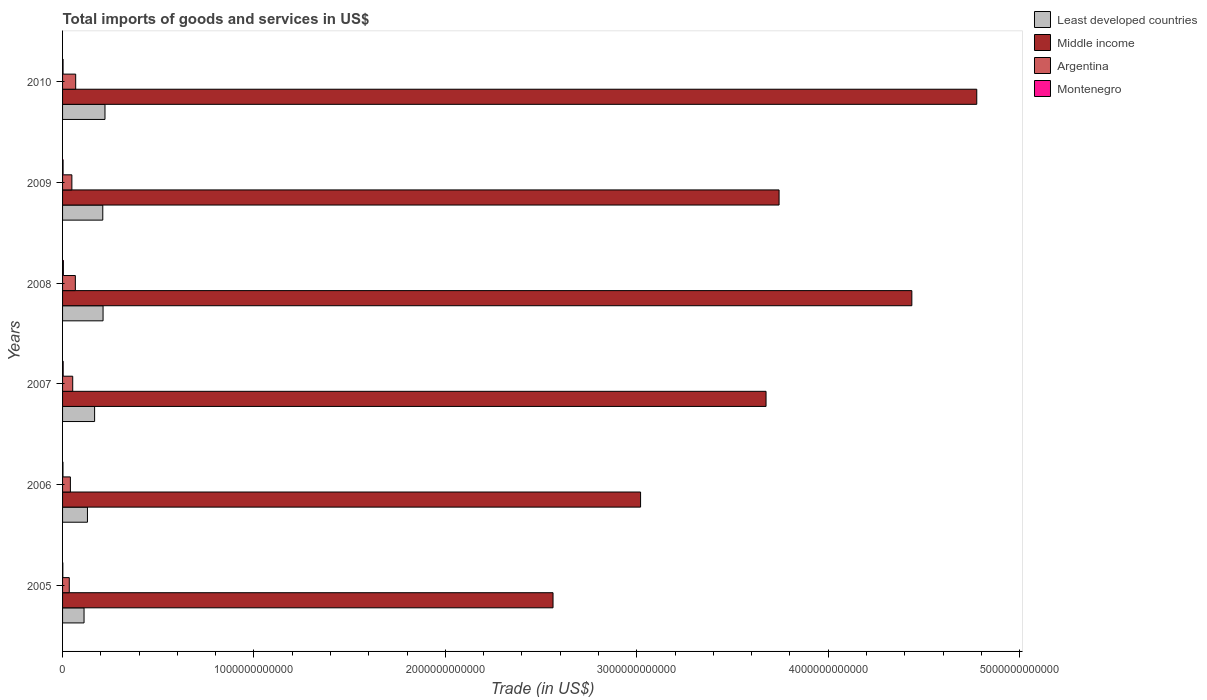How many bars are there on the 5th tick from the bottom?
Make the answer very short. 4. In how many cases, is the number of bars for a given year not equal to the number of legend labels?
Your answer should be very brief. 0. What is the total imports of goods and services in Middle income in 2006?
Offer a terse response. 3.02e+12. Across all years, what is the maximum total imports of goods and services in Least developed countries?
Offer a very short reply. 2.22e+11. Across all years, what is the minimum total imports of goods and services in Argentina?
Make the answer very short. 3.51e+1. In which year was the total imports of goods and services in Middle income minimum?
Keep it short and to the point. 2005. What is the total total imports of goods and services in Montenegro in the graph?
Provide a short and direct response. 1.62e+1. What is the difference between the total imports of goods and services in Middle income in 2006 and that in 2009?
Make the answer very short. -7.24e+11. What is the difference between the total imports of goods and services in Least developed countries in 2010 and the total imports of goods and services in Middle income in 2009?
Provide a short and direct response. -3.52e+12. What is the average total imports of goods and services in Middle income per year?
Ensure brevity in your answer.  3.70e+12. In the year 2008, what is the difference between the total imports of goods and services in Montenegro and total imports of goods and services in Middle income?
Keep it short and to the point. -4.43e+12. What is the ratio of the total imports of goods and services in Least developed countries in 2008 to that in 2009?
Provide a succinct answer. 1.01. Is the total imports of goods and services in Middle income in 2006 less than that in 2008?
Ensure brevity in your answer.  Yes. What is the difference between the highest and the second highest total imports of goods and services in Argentina?
Make the answer very short. 1.74e+09. What is the difference between the highest and the lowest total imports of goods and services in Middle income?
Ensure brevity in your answer.  2.21e+12. In how many years, is the total imports of goods and services in Middle income greater than the average total imports of goods and services in Middle income taken over all years?
Offer a very short reply. 3. Is the sum of the total imports of goods and services in Least developed countries in 2006 and 2007 greater than the maximum total imports of goods and services in Middle income across all years?
Offer a very short reply. No. Is it the case that in every year, the sum of the total imports of goods and services in Least developed countries and total imports of goods and services in Montenegro is greater than the sum of total imports of goods and services in Middle income and total imports of goods and services in Argentina?
Make the answer very short. No. What does the 4th bar from the top in 2006 represents?
Your answer should be very brief. Least developed countries. Is it the case that in every year, the sum of the total imports of goods and services in Middle income and total imports of goods and services in Argentina is greater than the total imports of goods and services in Montenegro?
Offer a very short reply. Yes. How many bars are there?
Offer a terse response. 24. Are all the bars in the graph horizontal?
Keep it short and to the point. Yes. How many years are there in the graph?
Provide a succinct answer. 6. What is the difference between two consecutive major ticks on the X-axis?
Provide a short and direct response. 1.00e+12. Does the graph contain grids?
Your answer should be compact. No. How are the legend labels stacked?
Ensure brevity in your answer.  Vertical. What is the title of the graph?
Your answer should be very brief. Total imports of goods and services in US$. Does "Turkey" appear as one of the legend labels in the graph?
Make the answer very short. No. What is the label or title of the X-axis?
Make the answer very short. Trade (in US$). What is the label or title of the Y-axis?
Offer a terse response. Years. What is the Trade (in US$) in Least developed countries in 2005?
Make the answer very short. 1.12e+11. What is the Trade (in US$) in Middle income in 2005?
Offer a terse response. 2.56e+12. What is the Trade (in US$) in Argentina in 2005?
Make the answer very short. 3.51e+1. What is the Trade (in US$) in Montenegro in 2005?
Your response must be concise. 1.38e+09. What is the Trade (in US$) in Least developed countries in 2006?
Your response must be concise. 1.30e+11. What is the Trade (in US$) in Middle income in 2006?
Give a very brief answer. 3.02e+12. What is the Trade (in US$) in Argentina in 2006?
Provide a succinct answer. 4.09e+1. What is the Trade (in US$) in Montenegro in 2006?
Your response must be concise. 2.13e+09. What is the Trade (in US$) in Least developed countries in 2007?
Give a very brief answer. 1.67e+11. What is the Trade (in US$) in Middle income in 2007?
Give a very brief answer. 3.68e+12. What is the Trade (in US$) of Argentina in 2007?
Keep it short and to the point. 5.30e+1. What is the Trade (in US$) of Montenegro in 2007?
Your answer should be compact. 3.18e+09. What is the Trade (in US$) in Least developed countries in 2008?
Provide a succinct answer. 2.12e+11. What is the Trade (in US$) of Middle income in 2008?
Give a very brief answer. 4.44e+12. What is the Trade (in US$) of Argentina in 2008?
Your answer should be very brief. 6.68e+1. What is the Trade (in US$) in Montenegro in 2008?
Offer a terse response. 4.25e+09. What is the Trade (in US$) in Least developed countries in 2009?
Keep it short and to the point. 2.10e+11. What is the Trade (in US$) of Middle income in 2009?
Keep it short and to the point. 3.74e+12. What is the Trade (in US$) of Argentina in 2009?
Offer a terse response. 4.87e+1. What is the Trade (in US$) of Montenegro in 2009?
Your answer should be very brief. 2.71e+09. What is the Trade (in US$) of Least developed countries in 2010?
Give a very brief answer. 2.22e+11. What is the Trade (in US$) in Middle income in 2010?
Ensure brevity in your answer.  4.78e+12. What is the Trade (in US$) of Argentina in 2010?
Provide a succinct answer. 6.85e+1. What is the Trade (in US$) in Montenegro in 2010?
Your response must be concise. 2.60e+09. Across all years, what is the maximum Trade (in US$) in Least developed countries?
Make the answer very short. 2.22e+11. Across all years, what is the maximum Trade (in US$) in Middle income?
Your response must be concise. 4.78e+12. Across all years, what is the maximum Trade (in US$) in Argentina?
Your answer should be compact. 6.85e+1. Across all years, what is the maximum Trade (in US$) of Montenegro?
Ensure brevity in your answer.  4.25e+09. Across all years, what is the minimum Trade (in US$) in Least developed countries?
Keep it short and to the point. 1.12e+11. Across all years, what is the minimum Trade (in US$) of Middle income?
Your answer should be very brief. 2.56e+12. Across all years, what is the minimum Trade (in US$) in Argentina?
Your response must be concise. 3.51e+1. Across all years, what is the minimum Trade (in US$) of Montenegro?
Offer a terse response. 1.38e+09. What is the total Trade (in US$) of Least developed countries in the graph?
Make the answer very short. 1.05e+12. What is the total Trade (in US$) in Middle income in the graph?
Offer a very short reply. 2.22e+13. What is the total Trade (in US$) in Argentina in the graph?
Offer a terse response. 3.13e+11. What is the total Trade (in US$) in Montenegro in the graph?
Offer a terse response. 1.62e+1. What is the difference between the Trade (in US$) of Least developed countries in 2005 and that in 2006?
Keep it short and to the point. -1.78e+1. What is the difference between the Trade (in US$) in Middle income in 2005 and that in 2006?
Make the answer very short. -4.57e+11. What is the difference between the Trade (in US$) of Argentina in 2005 and that in 2006?
Offer a terse response. -5.76e+09. What is the difference between the Trade (in US$) of Montenegro in 2005 and that in 2006?
Provide a short and direct response. -7.54e+08. What is the difference between the Trade (in US$) in Least developed countries in 2005 and that in 2007?
Provide a succinct answer. -5.52e+1. What is the difference between the Trade (in US$) of Middle income in 2005 and that in 2007?
Keep it short and to the point. -1.11e+12. What is the difference between the Trade (in US$) of Argentina in 2005 and that in 2007?
Give a very brief answer. -1.80e+1. What is the difference between the Trade (in US$) of Montenegro in 2005 and that in 2007?
Provide a short and direct response. -1.80e+09. What is the difference between the Trade (in US$) in Least developed countries in 2005 and that in 2008?
Offer a terse response. -9.94e+1. What is the difference between the Trade (in US$) of Middle income in 2005 and that in 2008?
Make the answer very short. -1.87e+12. What is the difference between the Trade (in US$) in Argentina in 2005 and that in 2008?
Offer a terse response. -3.17e+1. What is the difference between the Trade (in US$) in Montenegro in 2005 and that in 2008?
Offer a terse response. -2.87e+09. What is the difference between the Trade (in US$) in Least developed countries in 2005 and that in 2009?
Make the answer very short. -9.79e+1. What is the difference between the Trade (in US$) of Middle income in 2005 and that in 2009?
Keep it short and to the point. -1.18e+12. What is the difference between the Trade (in US$) of Argentina in 2005 and that in 2009?
Offer a terse response. -1.36e+1. What is the difference between the Trade (in US$) in Montenegro in 2005 and that in 2009?
Keep it short and to the point. -1.33e+09. What is the difference between the Trade (in US$) of Least developed countries in 2005 and that in 2010?
Ensure brevity in your answer.  -1.09e+11. What is the difference between the Trade (in US$) of Middle income in 2005 and that in 2010?
Your answer should be very brief. -2.21e+12. What is the difference between the Trade (in US$) of Argentina in 2005 and that in 2010?
Give a very brief answer. -3.34e+1. What is the difference between the Trade (in US$) of Montenegro in 2005 and that in 2010?
Your answer should be very brief. -1.22e+09. What is the difference between the Trade (in US$) in Least developed countries in 2006 and that in 2007?
Your response must be concise. -3.74e+1. What is the difference between the Trade (in US$) of Middle income in 2006 and that in 2007?
Your answer should be very brief. -6.56e+11. What is the difference between the Trade (in US$) in Argentina in 2006 and that in 2007?
Your response must be concise. -1.22e+1. What is the difference between the Trade (in US$) in Montenegro in 2006 and that in 2007?
Your response must be concise. -1.05e+09. What is the difference between the Trade (in US$) in Least developed countries in 2006 and that in 2008?
Make the answer very short. -8.16e+1. What is the difference between the Trade (in US$) of Middle income in 2006 and that in 2008?
Provide a short and direct response. -1.42e+12. What is the difference between the Trade (in US$) of Argentina in 2006 and that in 2008?
Keep it short and to the point. -2.59e+1. What is the difference between the Trade (in US$) of Montenegro in 2006 and that in 2008?
Offer a very short reply. -2.12e+09. What is the difference between the Trade (in US$) in Least developed countries in 2006 and that in 2009?
Make the answer very short. -8.01e+1. What is the difference between the Trade (in US$) in Middle income in 2006 and that in 2009?
Keep it short and to the point. -7.24e+11. What is the difference between the Trade (in US$) in Argentina in 2006 and that in 2009?
Your answer should be very brief. -7.80e+09. What is the difference between the Trade (in US$) in Montenegro in 2006 and that in 2009?
Provide a succinct answer. -5.77e+08. What is the difference between the Trade (in US$) in Least developed countries in 2006 and that in 2010?
Keep it short and to the point. -9.16e+1. What is the difference between the Trade (in US$) of Middle income in 2006 and that in 2010?
Provide a succinct answer. -1.76e+12. What is the difference between the Trade (in US$) of Argentina in 2006 and that in 2010?
Provide a succinct answer. -2.77e+1. What is the difference between the Trade (in US$) of Montenegro in 2006 and that in 2010?
Give a very brief answer. -4.64e+08. What is the difference between the Trade (in US$) in Least developed countries in 2007 and that in 2008?
Your response must be concise. -4.42e+1. What is the difference between the Trade (in US$) in Middle income in 2007 and that in 2008?
Your answer should be very brief. -7.62e+11. What is the difference between the Trade (in US$) of Argentina in 2007 and that in 2008?
Give a very brief answer. -1.37e+1. What is the difference between the Trade (in US$) of Montenegro in 2007 and that in 2008?
Offer a terse response. -1.07e+09. What is the difference between the Trade (in US$) of Least developed countries in 2007 and that in 2009?
Provide a short and direct response. -4.27e+1. What is the difference between the Trade (in US$) in Middle income in 2007 and that in 2009?
Give a very brief answer. -6.81e+1. What is the difference between the Trade (in US$) of Argentina in 2007 and that in 2009?
Offer a very short reply. 4.40e+09. What is the difference between the Trade (in US$) in Montenegro in 2007 and that in 2009?
Your answer should be very brief. 4.72e+08. What is the difference between the Trade (in US$) of Least developed countries in 2007 and that in 2010?
Your response must be concise. -5.42e+1. What is the difference between the Trade (in US$) of Middle income in 2007 and that in 2010?
Your response must be concise. -1.10e+12. What is the difference between the Trade (in US$) in Argentina in 2007 and that in 2010?
Ensure brevity in your answer.  -1.55e+1. What is the difference between the Trade (in US$) in Montenegro in 2007 and that in 2010?
Keep it short and to the point. 5.84e+08. What is the difference between the Trade (in US$) in Least developed countries in 2008 and that in 2009?
Provide a short and direct response. 1.49e+09. What is the difference between the Trade (in US$) in Middle income in 2008 and that in 2009?
Keep it short and to the point. 6.94e+11. What is the difference between the Trade (in US$) of Argentina in 2008 and that in 2009?
Keep it short and to the point. 1.81e+1. What is the difference between the Trade (in US$) in Montenegro in 2008 and that in 2009?
Give a very brief answer. 1.54e+09. What is the difference between the Trade (in US$) in Least developed countries in 2008 and that in 2010?
Keep it short and to the point. -1.00e+1. What is the difference between the Trade (in US$) of Middle income in 2008 and that in 2010?
Offer a terse response. -3.39e+11. What is the difference between the Trade (in US$) of Argentina in 2008 and that in 2010?
Provide a short and direct response. -1.74e+09. What is the difference between the Trade (in US$) in Montenegro in 2008 and that in 2010?
Ensure brevity in your answer.  1.65e+09. What is the difference between the Trade (in US$) in Least developed countries in 2009 and that in 2010?
Keep it short and to the point. -1.15e+1. What is the difference between the Trade (in US$) in Middle income in 2009 and that in 2010?
Your answer should be very brief. -1.03e+12. What is the difference between the Trade (in US$) of Argentina in 2009 and that in 2010?
Your answer should be compact. -1.99e+1. What is the difference between the Trade (in US$) of Montenegro in 2009 and that in 2010?
Offer a very short reply. 1.13e+08. What is the difference between the Trade (in US$) of Least developed countries in 2005 and the Trade (in US$) of Middle income in 2006?
Make the answer very short. -2.91e+12. What is the difference between the Trade (in US$) of Least developed countries in 2005 and the Trade (in US$) of Argentina in 2006?
Provide a short and direct response. 7.14e+1. What is the difference between the Trade (in US$) of Least developed countries in 2005 and the Trade (in US$) of Montenegro in 2006?
Provide a succinct answer. 1.10e+11. What is the difference between the Trade (in US$) of Middle income in 2005 and the Trade (in US$) of Argentina in 2006?
Ensure brevity in your answer.  2.52e+12. What is the difference between the Trade (in US$) in Middle income in 2005 and the Trade (in US$) in Montenegro in 2006?
Your answer should be compact. 2.56e+12. What is the difference between the Trade (in US$) in Argentina in 2005 and the Trade (in US$) in Montenegro in 2006?
Make the answer very short. 3.30e+1. What is the difference between the Trade (in US$) of Least developed countries in 2005 and the Trade (in US$) of Middle income in 2007?
Provide a short and direct response. -3.56e+12. What is the difference between the Trade (in US$) of Least developed countries in 2005 and the Trade (in US$) of Argentina in 2007?
Offer a terse response. 5.92e+1. What is the difference between the Trade (in US$) of Least developed countries in 2005 and the Trade (in US$) of Montenegro in 2007?
Ensure brevity in your answer.  1.09e+11. What is the difference between the Trade (in US$) in Middle income in 2005 and the Trade (in US$) in Argentina in 2007?
Ensure brevity in your answer.  2.51e+12. What is the difference between the Trade (in US$) of Middle income in 2005 and the Trade (in US$) of Montenegro in 2007?
Give a very brief answer. 2.56e+12. What is the difference between the Trade (in US$) in Argentina in 2005 and the Trade (in US$) in Montenegro in 2007?
Your answer should be compact. 3.19e+1. What is the difference between the Trade (in US$) of Least developed countries in 2005 and the Trade (in US$) of Middle income in 2008?
Your answer should be very brief. -4.32e+12. What is the difference between the Trade (in US$) of Least developed countries in 2005 and the Trade (in US$) of Argentina in 2008?
Your answer should be compact. 4.54e+1. What is the difference between the Trade (in US$) of Least developed countries in 2005 and the Trade (in US$) of Montenegro in 2008?
Offer a very short reply. 1.08e+11. What is the difference between the Trade (in US$) of Middle income in 2005 and the Trade (in US$) of Argentina in 2008?
Offer a very short reply. 2.50e+12. What is the difference between the Trade (in US$) in Middle income in 2005 and the Trade (in US$) in Montenegro in 2008?
Your response must be concise. 2.56e+12. What is the difference between the Trade (in US$) in Argentina in 2005 and the Trade (in US$) in Montenegro in 2008?
Your answer should be very brief. 3.08e+1. What is the difference between the Trade (in US$) in Least developed countries in 2005 and the Trade (in US$) in Middle income in 2009?
Your response must be concise. -3.63e+12. What is the difference between the Trade (in US$) of Least developed countries in 2005 and the Trade (in US$) of Argentina in 2009?
Offer a terse response. 6.36e+1. What is the difference between the Trade (in US$) of Least developed countries in 2005 and the Trade (in US$) of Montenegro in 2009?
Provide a short and direct response. 1.09e+11. What is the difference between the Trade (in US$) in Middle income in 2005 and the Trade (in US$) in Argentina in 2009?
Your answer should be very brief. 2.51e+12. What is the difference between the Trade (in US$) of Middle income in 2005 and the Trade (in US$) of Montenegro in 2009?
Offer a very short reply. 2.56e+12. What is the difference between the Trade (in US$) of Argentina in 2005 and the Trade (in US$) of Montenegro in 2009?
Make the answer very short. 3.24e+1. What is the difference between the Trade (in US$) of Least developed countries in 2005 and the Trade (in US$) of Middle income in 2010?
Your response must be concise. -4.66e+12. What is the difference between the Trade (in US$) in Least developed countries in 2005 and the Trade (in US$) in Argentina in 2010?
Provide a short and direct response. 4.37e+1. What is the difference between the Trade (in US$) in Least developed countries in 2005 and the Trade (in US$) in Montenegro in 2010?
Provide a short and direct response. 1.10e+11. What is the difference between the Trade (in US$) in Middle income in 2005 and the Trade (in US$) in Argentina in 2010?
Keep it short and to the point. 2.49e+12. What is the difference between the Trade (in US$) in Middle income in 2005 and the Trade (in US$) in Montenegro in 2010?
Give a very brief answer. 2.56e+12. What is the difference between the Trade (in US$) in Argentina in 2005 and the Trade (in US$) in Montenegro in 2010?
Give a very brief answer. 3.25e+1. What is the difference between the Trade (in US$) in Least developed countries in 2006 and the Trade (in US$) in Middle income in 2007?
Your answer should be very brief. -3.55e+12. What is the difference between the Trade (in US$) in Least developed countries in 2006 and the Trade (in US$) in Argentina in 2007?
Keep it short and to the point. 7.70e+1. What is the difference between the Trade (in US$) of Least developed countries in 2006 and the Trade (in US$) of Montenegro in 2007?
Your answer should be compact. 1.27e+11. What is the difference between the Trade (in US$) of Middle income in 2006 and the Trade (in US$) of Argentina in 2007?
Make the answer very short. 2.97e+12. What is the difference between the Trade (in US$) of Middle income in 2006 and the Trade (in US$) of Montenegro in 2007?
Provide a succinct answer. 3.02e+12. What is the difference between the Trade (in US$) in Argentina in 2006 and the Trade (in US$) in Montenegro in 2007?
Offer a terse response. 3.77e+1. What is the difference between the Trade (in US$) in Least developed countries in 2006 and the Trade (in US$) in Middle income in 2008?
Give a very brief answer. -4.31e+12. What is the difference between the Trade (in US$) in Least developed countries in 2006 and the Trade (in US$) in Argentina in 2008?
Ensure brevity in your answer.  6.32e+1. What is the difference between the Trade (in US$) of Least developed countries in 2006 and the Trade (in US$) of Montenegro in 2008?
Offer a terse response. 1.26e+11. What is the difference between the Trade (in US$) in Middle income in 2006 and the Trade (in US$) in Argentina in 2008?
Your answer should be compact. 2.95e+12. What is the difference between the Trade (in US$) of Middle income in 2006 and the Trade (in US$) of Montenegro in 2008?
Provide a short and direct response. 3.02e+12. What is the difference between the Trade (in US$) in Argentina in 2006 and the Trade (in US$) in Montenegro in 2008?
Provide a succinct answer. 3.66e+1. What is the difference between the Trade (in US$) in Least developed countries in 2006 and the Trade (in US$) in Middle income in 2009?
Give a very brief answer. -3.61e+12. What is the difference between the Trade (in US$) of Least developed countries in 2006 and the Trade (in US$) of Argentina in 2009?
Provide a short and direct response. 8.14e+1. What is the difference between the Trade (in US$) of Least developed countries in 2006 and the Trade (in US$) of Montenegro in 2009?
Provide a succinct answer. 1.27e+11. What is the difference between the Trade (in US$) of Middle income in 2006 and the Trade (in US$) of Argentina in 2009?
Give a very brief answer. 2.97e+12. What is the difference between the Trade (in US$) of Middle income in 2006 and the Trade (in US$) of Montenegro in 2009?
Give a very brief answer. 3.02e+12. What is the difference between the Trade (in US$) in Argentina in 2006 and the Trade (in US$) in Montenegro in 2009?
Provide a succinct answer. 3.81e+1. What is the difference between the Trade (in US$) of Least developed countries in 2006 and the Trade (in US$) of Middle income in 2010?
Your response must be concise. -4.65e+12. What is the difference between the Trade (in US$) of Least developed countries in 2006 and the Trade (in US$) of Argentina in 2010?
Provide a succinct answer. 6.15e+1. What is the difference between the Trade (in US$) of Least developed countries in 2006 and the Trade (in US$) of Montenegro in 2010?
Your response must be concise. 1.27e+11. What is the difference between the Trade (in US$) in Middle income in 2006 and the Trade (in US$) in Argentina in 2010?
Provide a succinct answer. 2.95e+12. What is the difference between the Trade (in US$) of Middle income in 2006 and the Trade (in US$) of Montenegro in 2010?
Your answer should be compact. 3.02e+12. What is the difference between the Trade (in US$) of Argentina in 2006 and the Trade (in US$) of Montenegro in 2010?
Make the answer very short. 3.83e+1. What is the difference between the Trade (in US$) in Least developed countries in 2007 and the Trade (in US$) in Middle income in 2008?
Offer a very short reply. -4.27e+12. What is the difference between the Trade (in US$) of Least developed countries in 2007 and the Trade (in US$) of Argentina in 2008?
Your answer should be compact. 1.01e+11. What is the difference between the Trade (in US$) of Least developed countries in 2007 and the Trade (in US$) of Montenegro in 2008?
Give a very brief answer. 1.63e+11. What is the difference between the Trade (in US$) in Middle income in 2007 and the Trade (in US$) in Argentina in 2008?
Give a very brief answer. 3.61e+12. What is the difference between the Trade (in US$) in Middle income in 2007 and the Trade (in US$) in Montenegro in 2008?
Offer a very short reply. 3.67e+12. What is the difference between the Trade (in US$) in Argentina in 2007 and the Trade (in US$) in Montenegro in 2008?
Your answer should be compact. 4.88e+1. What is the difference between the Trade (in US$) in Least developed countries in 2007 and the Trade (in US$) in Middle income in 2009?
Make the answer very short. -3.58e+12. What is the difference between the Trade (in US$) of Least developed countries in 2007 and the Trade (in US$) of Argentina in 2009?
Provide a succinct answer. 1.19e+11. What is the difference between the Trade (in US$) in Least developed countries in 2007 and the Trade (in US$) in Montenegro in 2009?
Provide a succinct answer. 1.65e+11. What is the difference between the Trade (in US$) of Middle income in 2007 and the Trade (in US$) of Argentina in 2009?
Offer a terse response. 3.63e+12. What is the difference between the Trade (in US$) in Middle income in 2007 and the Trade (in US$) in Montenegro in 2009?
Provide a short and direct response. 3.67e+12. What is the difference between the Trade (in US$) of Argentina in 2007 and the Trade (in US$) of Montenegro in 2009?
Your answer should be very brief. 5.03e+1. What is the difference between the Trade (in US$) in Least developed countries in 2007 and the Trade (in US$) in Middle income in 2010?
Give a very brief answer. -4.61e+12. What is the difference between the Trade (in US$) of Least developed countries in 2007 and the Trade (in US$) of Argentina in 2010?
Offer a terse response. 9.89e+1. What is the difference between the Trade (in US$) in Least developed countries in 2007 and the Trade (in US$) in Montenegro in 2010?
Your answer should be compact. 1.65e+11. What is the difference between the Trade (in US$) of Middle income in 2007 and the Trade (in US$) of Argentina in 2010?
Offer a terse response. 3.61e+12. What is the difference between the Trade (in US$) of Middle income in 2007 and the Trade (in US$) of Montenegro in 2010?
Offer a very short reply. 3.67e+12. What is the difference between the Trade (in US$) in Argentina in 2007 and the Trade (in US$) in Montenegro in 2010?
Give a very brief answer. 5.05e+1. What is the difference between the Trade (in US$) of Least developed countries in 2008 and the Trade (in US$) of Middle income in 2009?
Provide a succinct answer. -3.53e+12. What is the difference between the Trade (in US$) of Least developed countries in 2008 and the Trade (in US$) of Argentina in 2009?
Your answer should be compact. 1.63e+11. What is the difference between the Trade (in US$) of Least developed countries in 2008 and the Trade (in US$) of Montenegro in 2009?
Ensure brevity in your answer.  2.09e+11. What is the difference between the Trade (in US$) of Middle income in 2008 and the Trade (in US$) of Argentina in 2009?
Offer a very short reply. 4.39e+12. What is the difference between the Trade (in US$) of Middle income in 2008 and the Trade (in US$) of Montenegro in 2009?
Keep it short and to the point. 4.43e+12. What is the difference between the Trade (in US$) of Argentina in 2008 and the Trade (in US$) of Montenegro in 2009?
Your response must be concise. 6.41e+1. What is the difference between the Trade (in US$) in Least developed countries in 2008 and the Trade (in US$) in Middle income in 2010?
Your answer should be compact. -4.56e+12. What is the difference between the Trade (in US$) of Least developed countries in 2008 and the Trade (in US$) of Argentina in 2010?
Provide a succinct answer. 1.43e+11. What is the difference between the Trade (in US$) in Least developed countries in 2008 and the Trade (in US$) in Montenegro in 2010?
Keep it short and to the point. 2.09e+11. What is the difference between the Trade (in US$) in Middle income in 2008 and the Trade (in US$) in Argentina in 2010?
Give a very brief answer. 4.37e+12. What is the difference between the Trade (in US$) of Middle income in 2008 and the Trade (in US$) of Montenegro in 2010?
Ensure brevity in your answer.  4.43e+12. What is the difference between the Trade (in US$) in Argentina in 2008 and the Trade (in US$) in Montenegro in 2010?
Provide a short and direct response. 6.42e+1. What is the difference between the Trade (in US$) in Least developed countries in 2009 and the Trade (in US$) in Middle income in 2010?
Ensure brevity in your answer.  -4.57e+12. What is the difference between the Trade (in US$) in Least developed countries in 2009 and the Trade (in US$) in Argentina in 2010?
Ensure brevity in your answer.  1.42e+11. What is the difference between the Trade (in US$) of Least developed countries in 2009 and the Trade (in US$) of Montenegro in 2010?
Your answer should be very brief. 2.07e+11. What is the difference between the Trade (in US$) of Middle income in 2009 and the Trade (in US$) of Argentina in 2010?
Give a very brief answer. 3.67e+12. What is the difference between the Trade (in US$) in Middle income in 2009 and the Trade (in US$) in Montenegro in 2010?
Keep it short and to the point. 3.74e+12. What is the difference between the Trade (in US$) of Argentina in 2009 and the Trade (in US$) of Montenegro in 2010?
Your answer should be very brief. 4.61e+1. What is the average Trade (in US$) of Least developed countries per year?
Make the answer very short. 1.75e+11. What is the average Trade (in US$) of Middle income per year?
Ensure brevity in your answer.  3.70e+12. What is the average Trade (in US$) in Argentina per year?
Make the answer very short. 5.22e+1. What is the average Trade (in US$) of Montenegro per year?
Keep it short and to the point. 2.71e+09. In the year 2005, what is the difference between the Trade (in US$) of Least developed countries and Trade (in US$) of Middle income?
Offer a terse response. -2.45e+12. In the year 2005, what is the difference between the Trade (in US$) of Least developed countries and Trade (in US$) of Argentina?
Give a very brief answer. 7.71e+1. In the year 2005, what is the difference between the Trade (in US$) of Least developed countries and Trade (in US$) of Montenegro?
Your response must be concise. 1.11e+11. In the year 2005, what is the difference between the Trade (in US$) of Middle income and Trade (in US$) of Argentina?
Provide a succinct answer. 2.53e+12. In the year 2005, what is the difference between the Trade (in US$) in Middle income and Trade (in US$) in Montenegro?
Offer a terse response. 2.56e+12. In the year 2005, what is the difference between the Trade (in US$) in Argentina and Trade (in US$) in Montenegro?
Your answer should be compact. 3.37e+1. In the year 2006, what is the difference between the Trade (in US$) of Least developed countries and Trade (in US$) of Middle income?
Your response must be concise. -2.89e+12. In the year 2006, what is the difference between the Trade (in US$) in Least developed countries and Trade (in US$) in Argentina?
Your answer should be compact. 8.92e+1. In the year 2006, what is the difference between the Trade (in US$) in Least developed countries and Trade (in US$) in Montenegro?
Your response must be concise. 1.28e+11. In the year 2006, what is the difference between the Trade (in US$) in Middle income and Trade (in US$) in Argentina?
Your answer should be very brief. 2.98e+12. In the year 2006, what is the difference between the Trade (in US$) in Middle income and Trade (in US$) in Montenegro?
Keep it short and to the point. 3.02e+12. In the year 2006, what is the difference between the Trade (in US$) of Argentina and Trade (in US$) of Montenegro?
Keep it short and to the point. 3.87e+1. In the year 2007, what is the difference between the Trade (in US$) of Least developed countries and Trade (in US$) of Middle income?
Your response must be concise. -3.51e+12. In the year 2007, what is the difference between the Trade (in US$) of Least developed countries and Trade (in US$) of Argentina?
Your response must be concise. 1.14e+11. In the year 2007, what is the difference between the Trade (in US$) in Least developed countries and Trade (in US$) in Montenegro?
Your response must be concise. 1.64e+11. In the year 2007, what is the difference between the Trade (in US$) of Middle income and Trade (in US$) of Argentina?
Keep it short and to the point. 3.62e+12. In the year 2007, what is the difference between the Trade (in US$) of Middle income and Trade (in US$) of Montenegro?
Provide a succinct answer. 3.67e+12. In the year 2007, what is the difference between the Trade (in US$) in Argentina and Trade (in US$) in Montenegro?
Your response must be concise. 4.99e+1. In the year 2008, what is the difference between the Trade (in US$) in Least developed countries and Trade (in US$) in Middle income?
Offer a terse response. -4.23e+12. In the year 2008, what is the difference between the Trade (in US$) of Least developed countries and Trade (in US$) of Argentina?
Provide a succinct answer. 1.45e+11. In the year 2008, what is the difference between the Trade (in US$) of Least developed countries and Trade (in US$) of Montenegro?
Your answer should be very brief. 2.07e+11. In the year 2008, what is the difference between the Trade (in US$) of Middle income and Trade (in US$) of Argentina?
Provide a succinct answer. 4.37e+12. In the year 2008, what is the difference between the Trade (in US$) of Middle income and Trade (in US$) of Montenegro?
Give a very brief answer. 4.43e+12. In the year 2008, what is the difference between the Trade (in US$) of Argentina and Trade (in US$) of Montenegro?
Provide a short and direct response. 6.25e+1. In the year 2009, what is the difference between the Trade (in US$) of Least developed countries and Trade (in US$) of Middle income?
Offer a terse response. -3.53e+12. In the year 2009, what is the difference between the Trade (in US$) in Least developed countries and Trade (in US$) in Argentina?
Offer a terse response. 1.61e+11. In the year 2009, what is the difference between the Trade (in US$) of Least developed countries and Trade (in US$) of Montenegro?
Provide a succinct answer. 2.07e+11. In the year 2009, what is the difference between the Trade (in US$) in Middle income and Trade (in US$) in Argentina?
Offer a very short reply. 3.69e+12. In the year 2009, what is the difference between the Trade (in US$) in Middle income and Trade (in US$) in Montenegro?
Provide a short and direct response. 3.74e+12. In the year 2009, what is the difference between the Trade (in US$) in Argentina and Trade (in US$) in Montenegro?
Provide a succinct answer. 4.59e+1. In the year 2010, what is the difference between the Trade (in US$) of Least developed countries and Trade (in US$) of Middle income?
Offer a very short reply. -4.55e+12. In the year 2010, what is the difference between the Trade (in US$) in Least developed countries and Trade (in US$) in Argentina?
Your answer should be very brief. 1.53e+11. In the year 2010, what is the difference between the Trade (in US$) in Least developed countries and Trade (in US$) in Montenegro?
Offer a very short reply. 2.19e+11. In the year 2010, what is the difference between the Trade (in US$) of Middle income and Trade (in US$) of Argentina?
Provide a short and direct response. 4.71e+12. In the year 2010, what is the difference between the Trade (in US$) of Middle income and Trade (in US$) of Montenegro?
Offer a terse response. 4.77e+12. In the year 2010, what is the difference between the Trade (in US$) in Argentina and Trade (in US$) in Montenegro?
Ensure brevity in your answer.  6.59e+1. What is the ratio of the Trade (in US$) in Least developed countries in 2005 to that in 2006?
Keep it short and to the point. 0.86. What is the ratio of the Trade (in US$) of Middle income in 2005 to that in 2006?
Offer a very short reply. 0.85. What is the ratio of the Trade (in US$) in Argentina in 2005 to that in 2006?
Ensure brevity in your answer.  0.86. What is the ratio of the Trade (in US$) in Montenegro in 2005 to that in 2006?
Make the answer very short. 0.65. What is the ratio of the Trade (in US$) of Least developed countries in 2005 to that in 2007?
Offer a very short reply. 0.67. What is the ratio of the Trade (in US$) of Middle income in 2005 to that in 2007?
Give a very brief answer. 0.7. What is the ratio of the Trade (in US$) of Argentina in 2005 to that in 2007?
Give a very brief answer. 0.66. What is the ratio of the Trade (in US$) of Montenegro in 2005 to that in 2007?
Offer a terse response. 0.43. What is the ratio of the Trade (in US$) in Least developed countries in 2005 to that in 2008?
Offer a very short reply. 0.53. What is the ratio of the Trade (in US$) of Middle income in 2005 to that in 2008?
Make the answer very short. 0.58. What is the ratio of the Trade (in US$) of Argentina in 2005 to that in 2008?
Provide a short and direct response. 0.53. What is the ratio of the Trade (in US$) of Montenegro in 2005 to that in 2008?
Your answer should be compact. 0.32. What is the ratio of the Trade (in US$) in Least developed countries in 2005 to that in 2009?
Offer a very short reply. 0.53. What is the ratio of the Trade (in US$) in Middle income in 2005 to that in 2009?
Make the answer very short. 0.68. What is the ratio of the Trade (in US$) of Argentina in 2005 to that in 2009?
Your answer should be very brief. 0.72. What is the ratio of the Trade (in US$) in Montenegro in 2005 to that in 2009?
Your answer should be very brief. 0.51. What is the ratio of the Trade (in US$) in Least developed countries in 2005 to that in 2010?
Ensure brevity in your answer.  0.51. What is the ratio of the Trade (in US$) of Middle income in 2005 to that in 2010?
Provide a succinct answer. 0.54. What is the ratio of the Trade (in US$) of Argentina in 2005 to that in 2010?
Ensure brevity in your answer.  0.51. What is the ratio of the Trade (in US$) in Montenegro in 2005 to that in 2010?
Keep it short and to the point. 0.53. What is the ratio of the Trade (in US$) in Least developed countries in 2006 to that in 2007?
Make the answer very short. 0.78. What is the ratio of the Trade (in US$) in Middle income in 2006 to that in 2007?
Your answer should be compact. 0.82. What is the ratio of the Trade (in US$) in Argentina in 2006 to that in 2007?
Give a very brief answer. 0.77. What is the ratio of the Trade (in US$) in Montenegro in 2006 to that in 2007?
Your answer should be compact. 0.67. What is the ratio of the Trade (in US$) in Least developed countries in 2006 to that in 2008?
Your answer should be very brief. 0.61. What is the ratio of the Trade (in US$) in Middle income in 2006 to that in 2008?
Make the answer very short. 0.68. What is the ratio of the Trade (in US$) in Argentina in 2006 to that in 2008?
Provide a short and direct response. 0.61. What is the ratio of the Trade (in US$) of Montenegro in 2006 to that in 2008?
Your answer should be compact. 0.5. What is the ratio of the Trade (in US$) of Least developed countries in 2006 to that in 2009?
Offer a very short reply. 0.62. What is the ratio of the Trade (in US$) in Middle income in 2006 to that in 2009?
Your answer should be compact. 0.81. What is the ratio of the Trade (in US$) of Argentina in 2006 to that in 2009?
Make the answer very short. 0.84. What is the ratio of the Trade (in US$) of Montenegro in 2006 to that in 2009?
Offer a terse response. 0.79. What is the ratio of the Trade (in US$) of Least developed countries in 2006 to that in 2010?
Give a very brief answer. 0.59. What is the ratio of the Trade (in US$) in Middle income in 2006 to that in 2010?
Provide a short and direct response. 0.63. What is the ratio of the Trade (in US$) of Argentina in 2006 to that in 2010?
Provide a succinct answer. 0.6. What is the ratio of the Trade (in US$) in Montenegro in 2006 to that in 2010?
Your answer should be compact. 0.82. What is the ratio of the Trade (in US$) of Least developed countries in 2007 to that in 2008?
Offer a very short reply. 0.79. What is the ratio of the Trade (in US$) of Middle income in 2007 to that in 2008?
Offer a terse response. 0.83. What is the ratio of the Trade (in US$) of Argentina in 2007 to that in 2008?
Make the answer very short. 0.79. What is the ratio of the Trade (in US$) in Montenegro in 2007 to that in 2008?
Your answer should be compact. 0.75. What is the ratio of the Trade (in US$) in Least developed countries in 2007 to that in 2009?
Ensure brevity in your answer.  0.8. What is the ratio of the Trade (in US$) of Middle income in 2007 to that in 2009?
Keep it short and to the point. 0.98. What is the ratio of the Trade (in US$) of Argentina in 2007 to that in 2009?
Provide a succinct answer. 1.09. What is the ratio of the Trade (in US$) of Montenegro in 2007 to that in 2009?
Your answer should be compact. 1.17. What is the ratio of the Trade (in US$) of Least developed countries in 2007 to that in 2010?
Keep it short and to the point. 0.76. What is the ratio of the Trade (in US$) of Middle income in 2007 to that in 2010?
Your response must be concise. 0.77. What is the ratio of the Trade (in US$) of Argentina in 2007 to that in 2010?
Ensure brevity in your answer.  0.77. What is the ratio of the Trade (in US$) in Montenegro in 2007 to that in 2010?
Your answer should be compact. 1.22. What is the ratio of the Trade (in US$) of Least developed countries in 2008 to that in 2009?
Make the answer very short. 1.01. What is the ratio of the Trade (in US$) of Middle income in 2008 to that in 2009?
Your response must be concise. 1.19. What is the ratio of the Trade (in US$) of Argentina in 2008 to that in 2009?
Ensure brevity in your answer.  1.37. What is the ratio of the Trade (in US$) of Montenegro in 2008 to that in 2009?
Your answer should be very brief. 1.57. What is the ratio of the Trade (in US$) of Least developed countries in 2008 to that in 2010?
Keep it short and to the point. 0.95. What is the ratio of the Trade (in US$) of Middle income in 2008 to that in 2010?
Your answer should be very brief. 0.93. What is the ratio of the Trade (in US$) in Argentina in 2008 to that in 2010?
Give a very brief answer. 0.97. What is the ratio of the Trade (in US$) of Montenegro in 2008 to that in 2010?
Make the answer very short. 1.64. What is the ratio of the Trade (in US$) in Least developed countries in 2009 to that in 2010?
Offer a very short reply. 0.95. What is the ratio of the Trade (in US$) in Middle income in 2009 to that in 2010?
Your answer should be compact. 0.78. What is the ratio of the Trade (in US$) of Argentina in 2009 to that in 2010?
Offer a terse response. 0.71. What is the ratio of the Trade (in US$) in Montenegro in 2009 to that in 2010?
Offer a terse response. 1.04. What is the difference between the highest and the second highest Trade (in US$) in Least developed countries?
Your answer should be very brief. 1.00e+1. What is the difference between the highest and the second highest Trade (in US$) of Middle income?
Give a very brief answer. 3.39e+11. What is the difference between the highest and the second highest Trade (in US$) in Argentina?
Provide a short and direct response. 1.74e+09. What is the difference between the highest and the second highest Trade (in US$) of Montenegro?
Your answer should be compact. 1.07e+09. What is the difference between the highest and the lowest Trade (in US$) in Least developed countries?
Your answer should be compact. 1.09e+11. What is the difference between the highest and the lowest Trade (in US$) of Middle income?
Your response must be concise. 2.21e+12. What is the difference between the highest and the lowest Trade (in US$) in Argentina?
Provide a succinct answer. 3.34e+1. What is the difference between the highest and the lowest Trade (in US$) in Montenegro?
Your answer should be compact. 2.87e+09. 